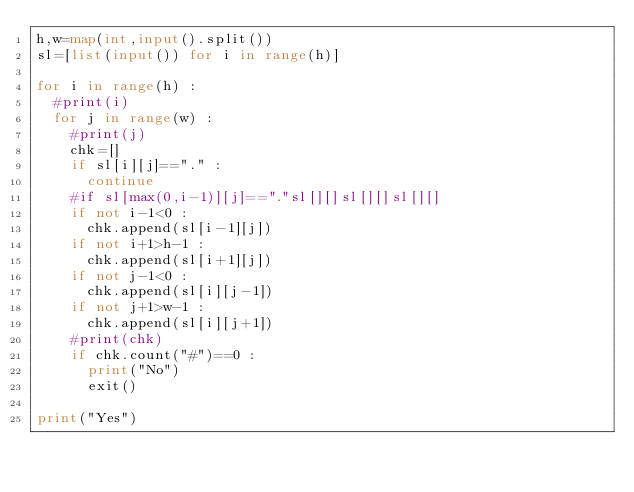<code> <loc_0><loc_0><loc_500><loc_500><_Python_>h,w=map(int,input().split())
sl=[list(input()) for i in range(h)]

for i in range(h) :
  #print(i)
  for j in range(w) :
    #print(j)
    chk=[]
    if sl[i][j]=="." :
      continue
    #if sl[max(0,i-1)][j]=="."sl[][]sl[][]sl[][]
    if not i-1<0 :
      chk.append(sl[i-1][j])
    if not i+1>h-1 :
      chk.append(sl[i+1][j])
    if not j-1<0 :
      chk.append(sl[i][j-1])
    if not j+1>w-1 :
      chk.append(sl[i][j+1])
    #print(chk)
    if chk.count("#")==0 :
      print("No")
      exit()
    
print("Yes")</code> 